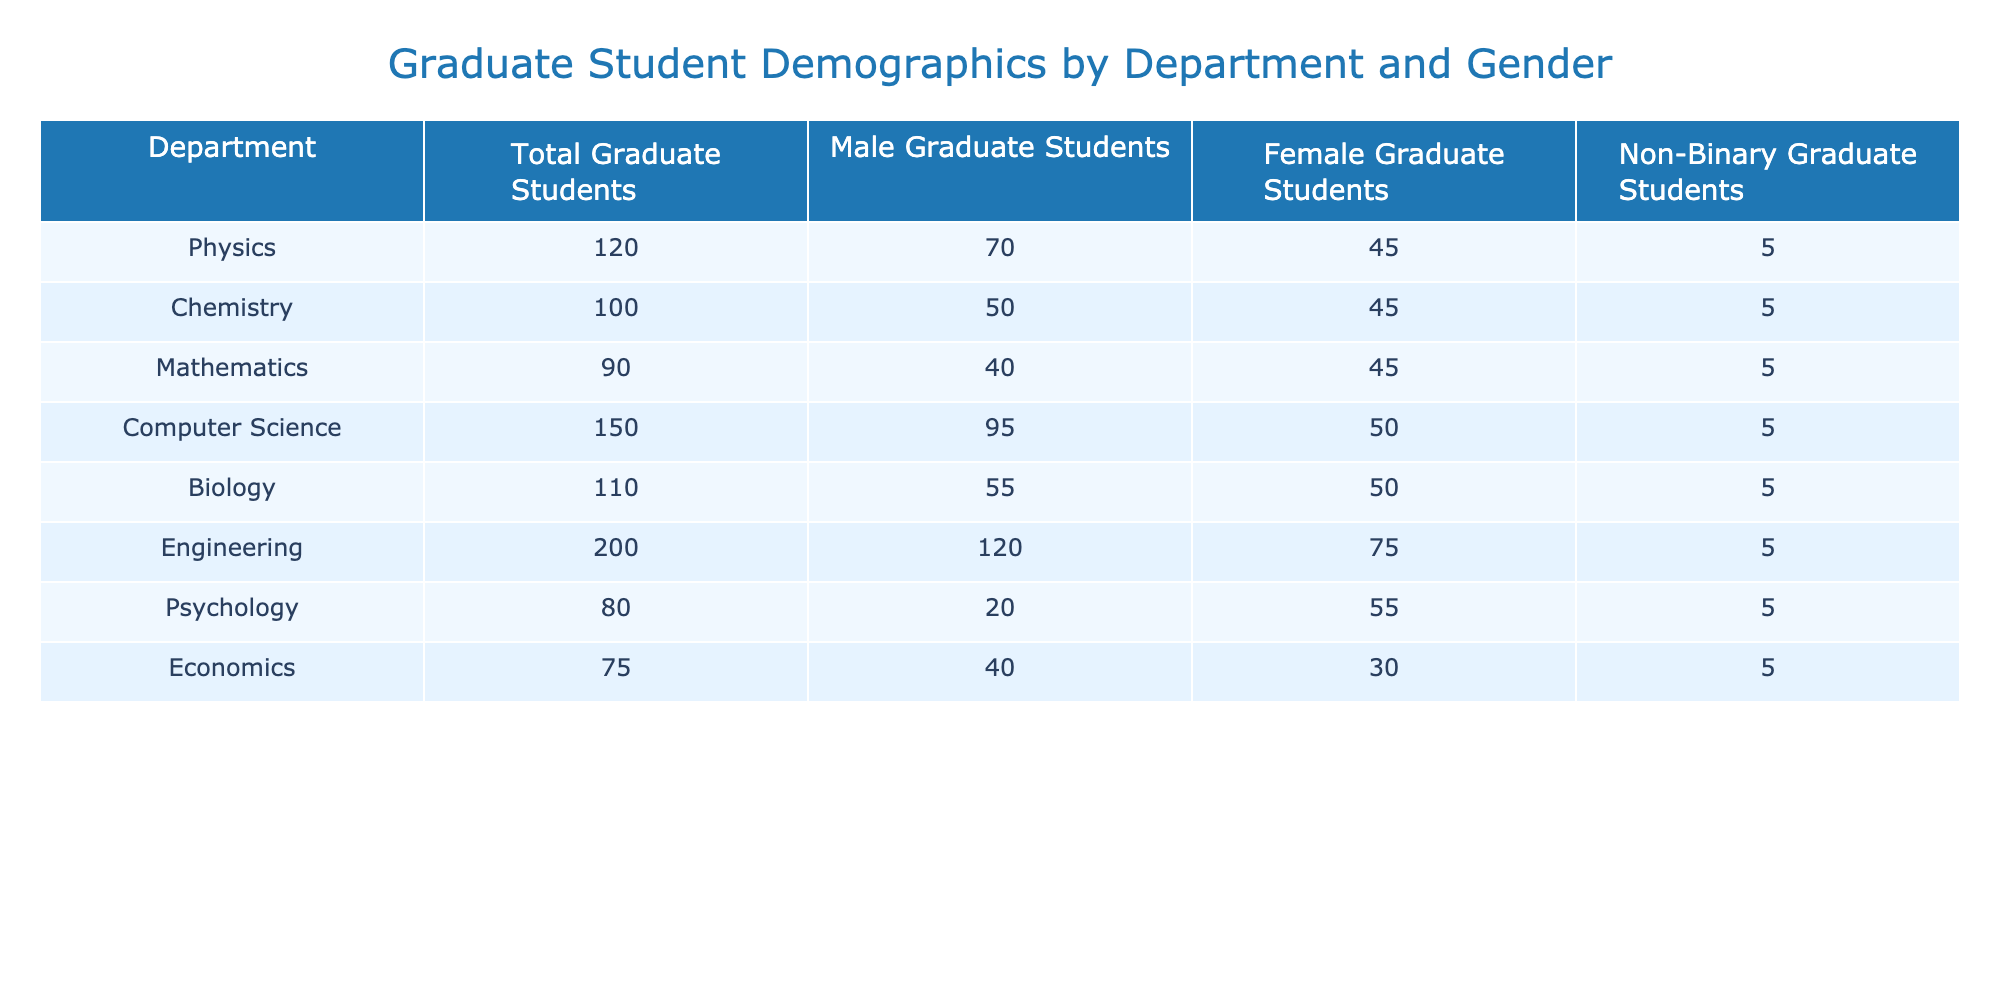What is the total number of graduate students in the Engineering department? The table shows that the Engineering department has 200 total graduate students listed under the column "Total Graduate Students."
Answer: 200 What is the gender distribution of graduate students in the Biology department? In the Biology department, there are 55 male, 50 female, and 5 non-binary graduate students. Summing these gives a total of 110, aligning with the total for the department.
Answer: 55 male, 50 female, 5 non-binary Is there a higher number of female graduate students in Psychology than in Economics? The Psychology department has 55 female graduate students, while the Economics department has 30 female graduate students. Since 55 is greater than 30, the statement is true.
Answer: Yes What is the average number of male graduate students across all departments? The total number of male graduate students is calculated as follows: 70 (Physics) + 50 (Chemistry) + 40 (Mathematics) + 95 (Computer Science) + 55 (Biology) + 120 (Engineering) + 20 (Psychology) + 40 (Economics) = 490. The number of departments is 8. Therefore, the average is 490/8 = 61.25.
Answer: 61.25 Which department has the highest number of non-binary graduate students? Each department has 5 non-binary graduate students listed. Since all values are identical, no department has a higher count than another.
Answer: All departments have the same count What is the total number of graduate students in the Chemistry and Mathematics departments combined? To find the total, we need to add the total graduate students from both departments: 100 (Chemistry) + 90 (Mathematics) = 190.
Answer: 190 Is the total number of male graduate students across all departments greater than 400? The total male students are 490 as calculated earlier. Since 490 is greater than 400, this statement is true.
Answer: Yes What percentage of graduate students in Physics are female? The number of female graduate students in Physics is 45 out of a total of 120. To find the percentage, calculate (45/120)*100 = 37.5%.
Answer: 37.5% 